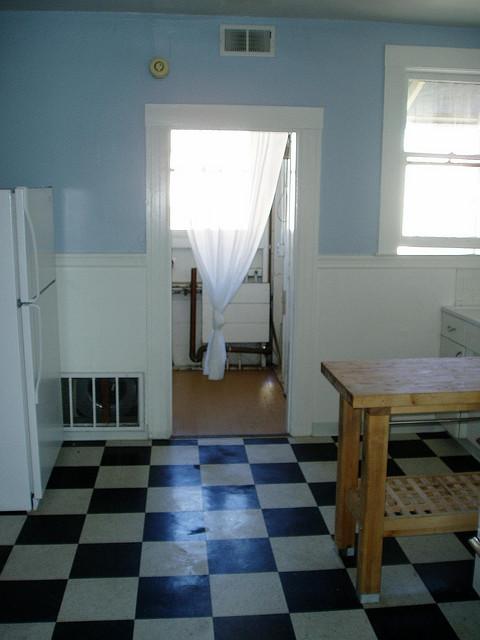How many black diamonds?
Concise answer only. 0. Is there a mirror in this room?
Be succinct. No. Is the window open?
Write a very short answer. Yes. What kind of room is this?
Answer briefly. Kitchen. Is the floor of wood?
Keep it brief. No. Is there an A/C vent on the wall?
Be succinct. Yes. What colors of tile are in the kitchen?
Quick response, please. Black and white. Is the floor completely tiled?
Be succinct. No. What color are the walls?
Answer briefly. Blue. What is the table made of?
Quick response, please. Wood. What electronic device is on the wall?
Concise answer only. Smoke detector. How many stars are on the wall?
Quick response, please. 0. What room is behind the dining room?
Concise answer only. Kitchen. What colors are the tile?
Write a very short answer. Black and white. What can you do behind the curtain?
Quick response, please. Cook. What color is the floor?
Answer briefly. Black and white. What color theme is this room?
Short answer required. Blue and white. Is this an open floor plan?
Give a very brief answer. No. Is this a living room?
Answer briefly. No. What is the decorating style of this room?
Be succinct. Retro. Is there a rug on the floor?
Quick response, please. No. What is the point of sheer fabric?
Concise answer only. Decoration. Which room is this?
Concise answer only. Kitchen. 